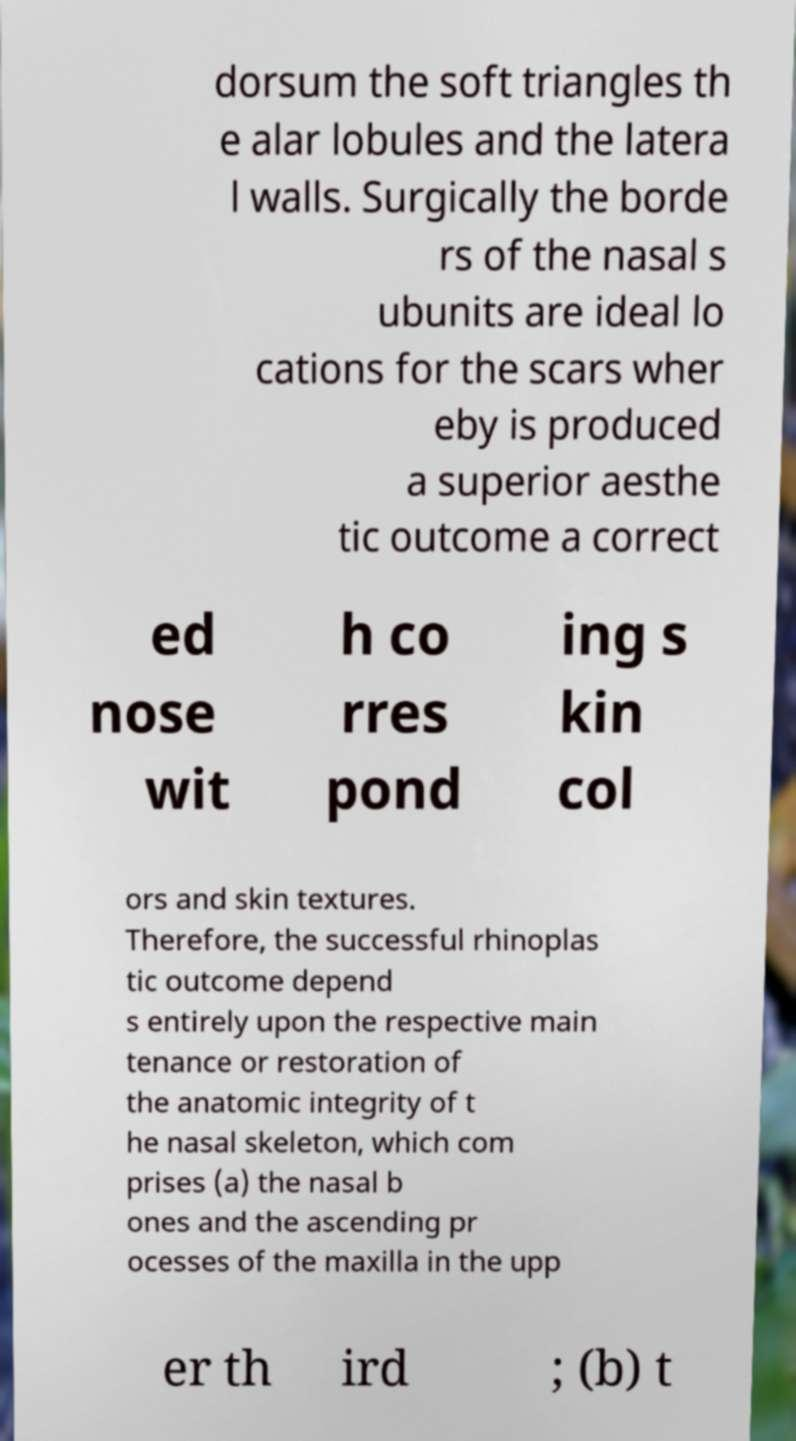I need the written content from this picture converted into text. Can you do that? dorsum the soft triangles th e alar lobules and the latera l walls. Surgically the borde rs of the nasal s ubunits are ideal lo cations for the scars wher eby is produced a superior aesthe tic outcome a correct ed nose wit h co rres pond ing s kin col ors and skin textures. Therefore, the successful rhinoplas tic outcome depend s entirely upon the respective main tenance or restoration of the anatomic integrity of t he nasal skeleton, which com prises (a) the nasal b ones and the ascending pr ocesses of the maxilla in the upp er th ird ; (b) t 